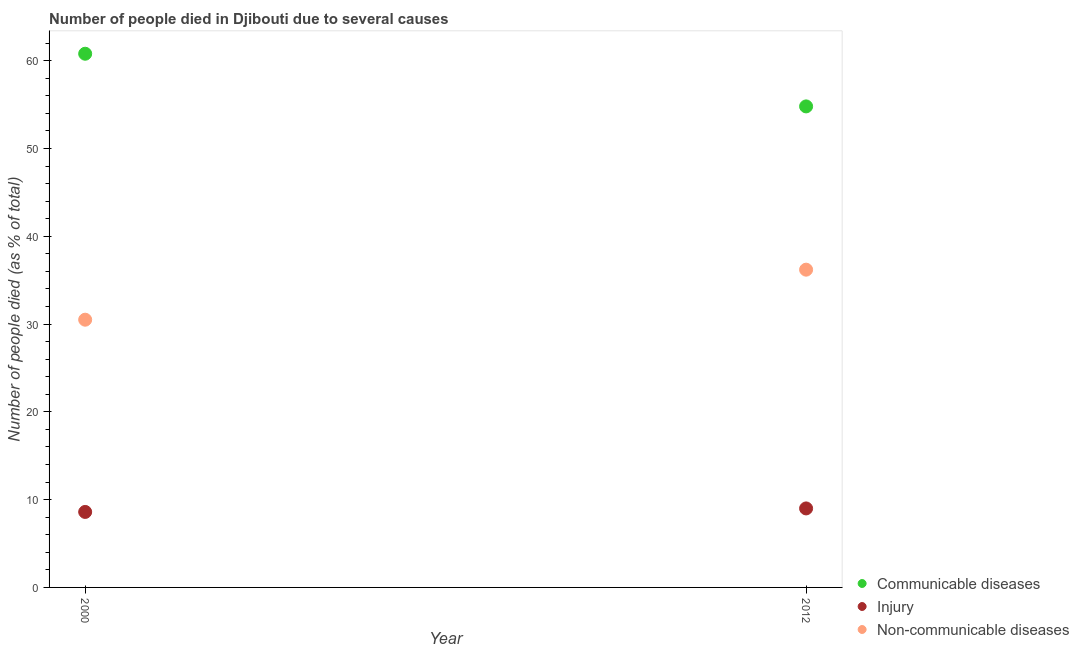How many different coloured dotlines are there?
Provide a succinct answer. 3. What is the number of people who dies of non-communicable diseases in 2012?
Offer a very short reply. 36.2. Across all years, what is the maximum number of people who dies of non-communicable diseases?
Your answer should be compact. 36.2. Across all years, what is the minimum number of people who dies of non-communicable diseases?
Your answer should be very brief. 30.5. What is the total number of people who dies of non-communicable diseases in the graph?
Offer a very short reply. 66.7. What is the difference between the number of people who died of communicable diseases in 2012 and the number of people who died of injury in 2000?
Offer a very short reply. 46.2. What is the average number of people who dies of non-communicable diseases per year?
Your answer should be compact. 33.35. In the year 2012, what is the difference between the number of people who died of injury and number of people who dies of non-communicable diseases?
Give a very brief answer. -27.2. In how many years, is the number of people who dies of non-communicable diseases greater than 36 %?
Offer a terse response. 1. What is the ratio of the number of people who dies of non-communicable diseases in 2000 to that in 2012?
Your response must be concise. 0.84. Is the number of people who dies of non-communicable diseases in 2000 less than that in 2012?
Ensure brevity in your answer.  Yes. In how many years, is the number of people who dies of non-communicable diseases greater than the average number of people who dies of non-communicable diseases taken over all years?
Ensure brevity in your answer.  1. Does the number of people who dies of non-communicable diseases monotonically increase over the years?
Provide a short and direct response. Yes. Is the number of people who died of injury strictly greater than the number of people who dies of non-communicable diseases over the years?
Make the answer very short. No. Is the number of people who died of injury strictly less than the number of people who dies of non-communicable diseases over the years?
Ensure brevity in your answer.  Yes. How many years are there in the graph?
Provide a succinct answer. 2. What is the difference between two consecutive major ticks on the Y-axis?
Your answer should be compact. 10. Does the graph contain grids?
Offer a terse response. No. Where does the legend appear in the graph?
Make the answer very short. Bottom right. How are the legend labels stacked?
Your answer should be compact. Vertical. What is the title of the graph?
Provide a succinct answer. Number of people died in Djibouti due to several causes. Does "Tertiary education" appear as one of the legend labels in the graph?
Offer a terse response. No. What is the label or title of the X-axis?
Ensure brevity in your answer.  Year. What is the label or title of the Y-axis?
Provide a short and direct response. Number of people died (as % of total). What is the Number of people died (as % of total) in Communicable diseases in 2000?
Make the answer very short. 60.8. What is the Number of people died (as % of total) in Injury in 2000?
Keep it short and to the point. 8.6. What is the Number of people died (as % of total) in Non-communicable diseases in 2000?
Offer a very short reply. 30.5. What is the Number of people died (as % of total) of Communicable diseases in 2012?
Give a very brief answer. 54.8. What is the Number of people died (as % of total) of Injury in 2012?
Provide a short and direct response. 9. What is the Number of people died (as % of total) in Non-communicable diseases in 2012?
Provide a succinct answer. 36.2. Across all years, what is the maximum Number of people died (as % of total) in Communicable diseases?
Your answer should be very brief. 60.8. Across all years, what is the maximum Number of people died (as % of total) of Non-communicable diseases?
Offer a very short reply. 36.2. Across all years, what is the minimum Number of people died (as % of total) in Communicable diseases?
Your response must be concise. 54.8. Across all years, what is the minimum Number of people died (as % of total) in Injury?
Make the answer very short. 8.6. Across all years, what is the minimum Number of people died (as % of total) of Non-communicable diseases?
Provide a short and direct response. 30.5. What is the total Number of people died (as % of total) of Communicable diseases in the graph?
Give a very brief answer. 115.6. What is the total Number of people died (as % of total) of Injury in the graph?
Your answer should be very brief. 17.6. What is the total Number of people died (as % of total) in Non-communicable diseases in the graph?
Provide a short and direct response. 66.7. What is the difference between the Number of people died (as % of total) in Communicable diseases in 2000 and that in 2012?
Provide a succinct answer. 6. What is the difference between the Number of people died (as % of total) of Communicable diseases in 2000 and the Number of people died (as % of total) of Injury in 2012?
Provide a succinct answer. 51.8. What is the difference between the Number of people died (as % of total) in Communicable diseases in 2000 and the Number of people died (as % of total) in Non-communicable diseases in 2012?
Make the answer very short. 24.6. What is the difference between the Number of people died (as % of total) in Injury in 2000 and the Number of people died (as % of total) in Non-communicable diseases in 2012?
Offer a very short reply. -27.6. What is the average Number of people died (as % of total) of Communicable diseases per year?
Provide a succinct answer. 57.8. What is the average Number of people died (as % of total) of Injury per year?
Offer a very short reply. 8.8. What is the average Number of people died (as % of total) of Non-communicable diseases per year?
Provide a short and direct response. 33.35. In the year 2000, what is the difference between the Number of people died (as % of total) in Communicable diseases and Number of people died (as % of total) in Injury?
Make the answer very short. 52.2. In the year 2000, what is the difference between the Number of people died (as % of total) of Communicable diseases and Number of people died (as % of total) of Non-communicable diseases?
Offer a very short reply. 30.3. In the year 2000, what is the difference between the Number of people died (as % of total) in Injury and Number of people died (as % of total) in Non-communicable diseases?
Your response must be concise. -21.9. In the year 2012, what is the difference between the Number of people died (as % of total) of Communicable diseases and Number of people died (as % of total) of Injury?
Ensure brevity in your answer.  45.8. In the year 2012, what is the difference between the Number of people died (as % of total) in Communicable diseases and Number of people died (as % of total) in Non-communicable diseases?
Offer a terse response. 18.6. In the year 2012, what is the difference between the Number of people died (as % of total) in Injury and Number of people died (as % of total) in Non-communicable diseases?
Keep it short and to the point. -27.2. What is the ratio of the Number of people died (as % of total) of Communicable diseases in 2000 to that in 2012?
Keep it short and to the point. 1.11. What is the ratio of the Number of people died (as % of total) in Injury in 2000 to that in 2012?
Offer a very short reply. 0.96. What is the ratio of the Number of people died (as % of total) in Non-communicable diseases in 2000 to that in 2012?
Offer a very short reply. 0.84. What is the difference between the highest and the second highest Number of people died (as % of total) in Communicable diseases?
Make the answer very short. 6. What is the difference between the highest and the second highest Number of people died (as % of total) of Non-communicable diseases?
Make the answer very short. 5.7. What is the difference between the highest and the lowest Number of people died (as % of total) in Communicable diseases?
Give a very brief answer. 6. What is the difference between the highest and the lowest Number of people died (as % of total) of Injury?
Provide a succinct answer. 0.4. 